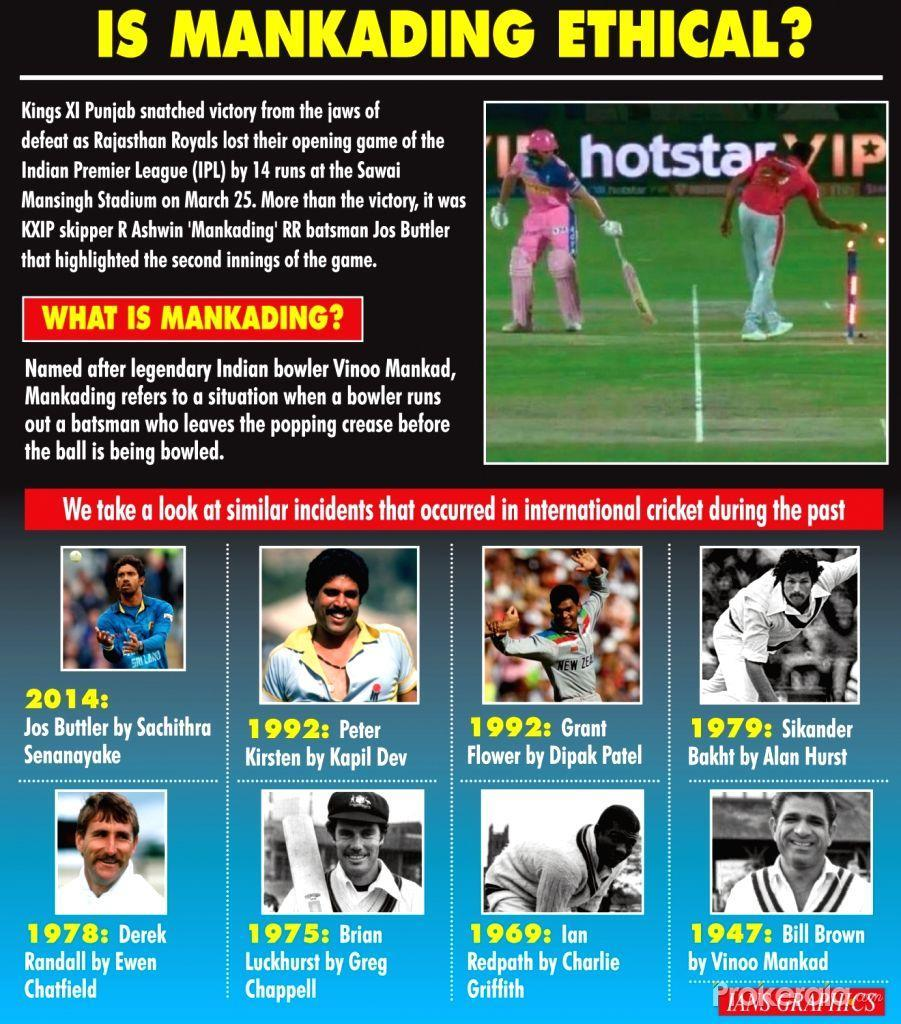How many Mankading incidents mentioned in this infographic?
Answer the question with a short phrase. 9 